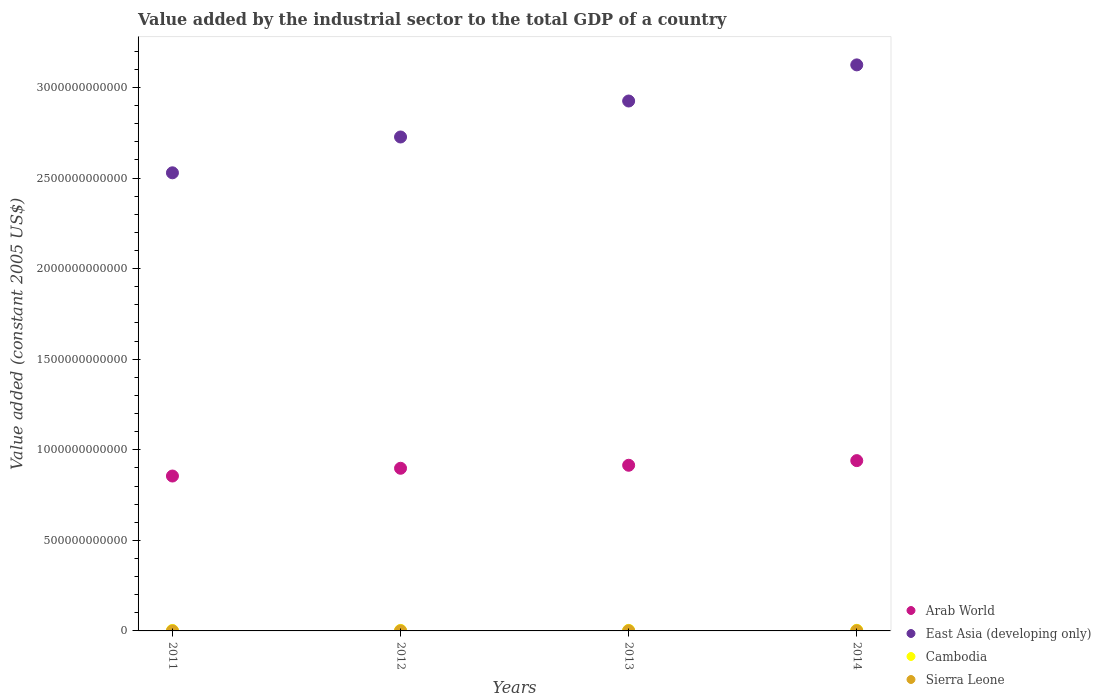How many different coloured dotlines are there?
Your response must be concise. 4. Is the number of dotlines equal to the number of legend labels?
Your response must be concise. Yes. What is the value added by the industrial sector in Cambodia in 2013?
Your answer should be compact. 3.00e+09. Across all years, what is the maximum value added by the industrial sector in Cambodia?
Make the answer very short. 3.29e+09. Across all years, what is the minimum value added by the industrial sector in East Asia (developing only)?
Offer a terse response. 2.53e+12. In which year was the value added by the industrial sector in East Asia (developing only) maximum?
Give a very brief answer. 2014. What is the total value added by the industrial sector in Cambodia in the graph?
Your answer should be very brief. 1.15e+1. What is the difference between the value added by the industrial sector in Sierra Leone in 2011 and that in 2012?
Your answer should be compact. -2.66e+08. What is the difference between the value added by the industrial sector in Arab World in 2011 and the value added by the industrial sector in Cambodia in 2013?
Provide a short and direct response. 8.52e+11. What is the average value added by the industrial sector in Sierra Leone per year?
Offer a very short reply. 6.73e+08. In the year 2011, what is the difference between the value added by the industrial sector in Sierra Leone and value added by the industrial sector in Arab World?
Keep it short and to the point. -8.55e+11. In how many years, is the value added by the industrial sector in Sierra Leone greater than 2800000000000 US$?
Your answer should be compact. 0. What is the ratio of the value added by the industrial sector in Sierra Leone in 2012 to that in 2014?
Your answer should be compact. 0.44. Is the value added by the industrial sector in East Asia (developing only) in 2011 less than that in 2013?
Your answer should be compact. Yes. Is the difference between the value added by the industrial sector in Sierra Leone in 2013 and 2014 greater than the difference between the value added by the industrial sector in Arab World in 2013 and 2014?
Offer a terse response. Yes. What is the difference between the highest and the second highest value added by the industrial sector in Cambodia?
Give a very brief answer. 2.95e+08. What is the difference between the highest and the lowest value added by the industrial sector in Cambodia?
Your response must be concise. 8.21e+08. Is it the case that in every year, the sum of the value added by the industrial sector in Cambodia and value added by the industrial sector in Arab World  is greater than the value added by the industrial sector in East Asia (developing only)?
Offer a very short reply. No. Is the value added by the industrial sector in Sierra Leone strictly greater than the value added by the industrial sector in Cambodia over the years?
Provide a succinct answer. No. Is the value added by the industrial sector in Arab World strictly less than the value added by the industrial sector in Cambodia over the years?
Offer a very short reply. No. What is the difference between two consecutive major ticks on the Y-axis?
Give a very brief answer. 5.00e+11. Does the graph contain any zero values?
Provide a short and direct response. No. Does the graph contain grids?
Provide a short and direct response. No. How are the legend labels stacked?
Your response must be concise. Vertical. What is the title of the graph?
Offer a very short reply. Value added by the industrial sector to the total GDP of a country. Does "Guyana" appear as one of the legend labels in the graph?
Your response must be concise. No. What is the label or title of the X-axis?
Provide a succinct answer. Years. What is the label or title of the Y-axis?
Ensure brevity in your answer.  Value added (constant 2005 US$). What is the Value added (constant 2005 US$) in Arab World in 2011?
Make the answer very short. 8.55e+11. What is the Value added (constant 2005 US$) in East Asia (developing only) in 2011?
Your answer should be compact. 2.53e+12. What is the Value added (constant 2005 US$) in Cambodia in 2011?
Your answer should be very brief. 2.47e+09. What is the Value added (constant 2005 US$) in Sierra Leone in 2011?
Keep it short and to the point. 2.09e+08. What is the Value added (constant 2005 US$) in Arab World in 2012?
Give a very brief answer. 8.98e+11. What is the Value added (constant 2005 US$) of East Asia (developing only) in 2012?
Give a very brief answer. 2.73e+12. What is the Value added (constant 2005 US$) in Cambodia in 2012?
Offer a very short reply. 2.70e+09. What is the Value added (constant 2005 US$) of Sierra Leone in 2012?
Your answer should be compact. 4.75e+08. What is the Value added (constant 2005 US$) of Arab World in 2013?
Offer a terse response. 9.15e+11. What is the Value added (constant 2005 US$) in East Asia (developing only) in 2013?
Keep it short and to the point. 2.93e+12. What is the Value added (constant 2005 US$) of Cambodia in 2013?
Your response must be concise. 3.00e+09. What is the Value added (constant 2005 US$) in Sierra Leone in 2013?
Keep it short and to the point. 9.39e+08. What is the Value added (constant 2005 US$) in Arab World in 2014?
Offer a very short reply. 9.40e+11. What is the Value added (constant 2005 US$) of East Asia (developing only) in 2014?
Provide a short and direct response. 3.12e+12. What is the Value added (constant 2005 US$) in Cambodia in 2014?
Your answer should be compact. 3.29e+09. What is the Value added (constant 2005 US$) of Sierra Leone in 2014?
Make the answer very short. 1.07e+09. Across all years, what is the maximum Value added (constant 2005 US$) in Arab World?
Your answer should be compact. 9.40e+11. Across all years, what is the maximum Value added (constant 2005 US$) in East Asia (developing only)?
Offer a terse response. 3.12e+12. Across all years, what is the maximum Value added (constant 2005 US$) in Cambodia?
Ensure brevity in your answer.  3.29e+09. Across all years, what is the maximum Value added (constant 2005 US$) in Sierra Leone?
Offer a terse response. 1.07e+09. Across all years, what is the minimum Value added (constant 2005 US$) of Arab World?
Provide a succinct answer. 8.55e+11. Across all years, what is the minimum Value added (constant 2005 US$) of East Asia (developing only)?
Ensure brevity in your answer.  2.53e+12. Across all years, what is the minimum Value added (constant 2005 US$) in Cambodia?
Your answer should be very brief. 2.47e+09. Across all years, what is the minimum Value added (constant 2005 US$) of Sierra Leone?
Offer a terse response. 2.09e+08. What is the total Value added (constant 2005 US$) of Arab World in the graph?
Give a very brief answer. 3.61e+12. What is the total Value added (constant 2005 US$) of East Asia (developing only) in the graph?
Your answer should be compact. 1.13e+13. What is the total Value added (constant 2005 US$) in Cambodia in the graph?
Make the answer very short. 1.15e+1. What is the total Value added (constant 2005 US$) of Sierra Leone in the graph?
Ensure brevity in your answer.  2.69e+09. What is the difference between the Value added (constant 2005 US$) of Arab World in 2011 and that in 2012?
Offer a terse response. -4.28e+1. What is the difference between the Value added (constant 2005 US$) of East Asia (developing only) in 2011 and that in 2012?
Your answer should be very brief. -1.98e+11. What is the difference between the Value added (constant 2005 US$) of Cambodia in 2011 and that in 2012?
Provide a succinct answer. -2.30e+08. What is the difference between the Value added (constant 2005 US$) in Sierra Leone in 2011 and that in 2012?
Your response must be concise. -2.66e+08. What is the difference between the Value added (constant 2005 US$) of Arab World in 2011 and that in 2013?
Provide a short and direct response. -5.94e+1. What is the difference between the Value added (constant 2005 US$) of East Asia (developing only) in 2011 and that in 2013?
Offer a terse response. -3.96e+11. What is the difference between the Value added (constant 2005 US$) in Cambodia in 2011 and that in 2013?
Offer a very short reply. -5.27e+08. What is the difference between the Value added (constant 2005 US$) of Sierra Leone in 2011 and that in 2013?
Give a very brief answer. -7.31e+08. What is the difference between the Value added (constant 2005 US$) in Arab World in 2011 and that in 2014?
Offer a terse response. -8.50e+1. What is the difference between the Value added (constant 2005 US$) in East Asia (developing only) in 2011 and that in 2014?
Keep it short and to the point. -5.96e+11. What is the difference between the Value added (constant 2005 US$) in Cambodia in 2011 and that in 2014?
Provide a short and direct response. -8.21e+08. What is the difference between the Value added (constant 2005 US$) of Sierra Leone in 2011 and that in 2014?
Ensure brevity in your answer.  -8.60e+08. What is the difference between the Value added (constant 2005 US$) in Arab World in 2012 and that in 2013?
Your answer should be very brief. -1.66e+1. What is the difference between the Value added (constant 2005 US$) in East Asia (developing only) in 2012 and that in 2013?
Your answer should be compact. -1.99e+11. What is the difference between the Value added (constant 2005 US$) of Cambodia in 2012 and that in 2013?
Keep it short and to the point. -2.96e+08. What is the difference between the Value added (constant 2005 US$) in Sierra Leone in 2012 and that in 2013?
Offer a terse response. -4.65e+08. What is the difference between the Value added (constant 2005 US$) of Arab World in 2012 and that in 2014?
Make the answer very short. -4.22e+1. What is the difference between the Value added (constant 2005 US$) in East Asia (developing only) in 2012 and that in 2014?
Your response must be concise. -3.98e+11. What is the difference between the Value added (constant 2005 US$) in Cambodia in 2012 and that in 2014?
Provide a short and direct response. -5.91e+08. What is the difference between the Value added (constant 2005 US$) of Sierra Leone in 2012 and that in 2014?
Offer a very short reply. -5.94e+08. What is the difference between the Value added (constant 2005 US$) of Arab World in 2013 and that in 2014?
Offer a terse response. -2.56e+1. What is the difference between the Value added (constant 2005 US$) in East Asia (developing only) in 2013 and that in 2014?
Your response must be concise. -2.00e+11. What is the difference between the Value added (constant 2005 US$) in Cambodia in 2013 and that in 2014?
Offer a very short reply. -2.95e+08. What is the difference between the Value added (constant 2005 US$) in Sierra Leone in 2013 and that in 2014?
Offer a terse response. -1.30e+08. What is the difference between the Value added (constant 2005 US$) in Arab World in 2011 and the Value added (constant 2005 US$) in East Asia (developing only) in 2012?
Give a very brief answer. -1.87e+12. What is the difference between the Value added (constant 2005 US$) of Arab World in 2011 and the Value added (constant 2005 US$) of Cambodia in 2012?
Give a very brief answer. 8.52e+11. What is the difference between the Value added (constant 2005 US$) of Arab World in 2011 and the Value added (constant 2005 US$) of Sierra Leone in 2012?
Make the answer very short. 8.55e+11. What is the difference between the Value added (constant 2005 US$) of East Asia (developing only) in 2011 and the Value added (constant 2005 US$) of Cambodia in 2012?
Ensure brevity in your answer.  2.53e+12. What is the difference between the Value added (constant 2005 US$) in East Asia (developing only) in 2011 and the Value added (constant 2005 US$) in Sierra Leone in 2012?
Your response must be concise. 2.53e+12. What is the difference between the Value added (constant 2005 US$) in Cambodia in 2011 and the Value added (constant 2005 US$) in Sierra Leone in 2012?
Your answer should be very brief. 1.99e+09. What is the difference between the Value added (constant 2005 US$) in Arab World in 2011 and the Value added (constant 2005 US$) in East Asia (developing only) in 2013?
Give a very brief answer. -2.07e+12. What is the difference between the Value added (constant 2005 US$) of Arab World in 2011 and the Value added (constant 2005 US$) of Cambodia in 2013?
Provide a succinct answer. 8.52e+11. What is the difference between the Value added (constant 2005 US$) of Arab World in 2011 and the Value added (constant 2005 US$) of Sierra Leone in 2013?
Offer a very short reply. 8.54e+11. What is the difference between the Value added (constant 2005 US$) of East Asia (developing only) in 2011 and the Value added (constant 2005 US$) of Cambodia in 2013?
Keep it short and to the point. 2.53e+12. What is the difference between the Value added (constant 2005 US$) of East Asia (developing only) in 2011 and the Value added (constant 2005 US$) of Sierra Leone in 2013?
Offer a very short reply. 2.53e+12. What is the difference between the Value added (constant 2005 US$) of Cambodia in 2011 and the Value added (constant 2005 US$) of Sierra Leone in 2013?
Provide a succinct answer. 1.53e+09. What is the difference between the Value added (constant 2005 US$) in Arab World in 2011 and the Value added (constant 2005 US$) in East Asia (developing only) in 2014?
Ensure brevity in your answer.  -2.27e+12. What is the difference between the Value added (constant 2005 US$) of Arab World in 2011 and the Value added (constant 2005 US$) of Cambodia in 2014?
Your answer should be compact. 8.52e+11. What is the difference between the Value added (constant 2005 US$) of Arab World in 2011 and the Value added (constant 2005 US$) of Sierra Leone in 2014?
Offer a very short reply. 8.54e+11. What is the difference between the Value added (constant 2005 US$) in East Asia (developing only) in 2011 and the Value added (constant 2005 US$) in Cambodia in 2014?
Provide a short and direct response. 2.53e+12. What is the difference between the Value added (constant 2005 US$) in East Asia (developing only) in 2011 and the Value added (constant 2005 US$) in Sierra Leone in 2014?
Provide a succinct answer. 2.53e+12. What is the difference between the Value added (constant 2005 US$) of Cambodia in 2011 and the Value added (constant 2005 US$) of Sierra Leone in 2014?
Ensure brevity in your answer.  1.40e+09. What is the difference between the Value added (constant 2005 US$) of Arab World in 2012 and the Value added (constant 2005 US$) of East Asia (developing only) in 2013?
Ensure brevity in your answer.  -2.03e+12. What is the difference between the Value added (constant 2005 US$) in Arab World in 2012 and the Value added (constant 2005 US$) in Cambodia in 2013?
Offer a terse response. 8.95e+11. What is the difference between the Value added (constant 2005 US$) of Arab World in 2012 and the Value added (constant 2005 US$) of Sierra Leone in 2013?
Your answer should be very brief. 8.97e+11. What is the difference between the Value added (constant 2005 US$) of East Asia (developing only) in 2012 and the Value added (constant 2005 US$) of Cambodia in 2013?
Ensure brevity in your answer.  2.72e+12. What is the difference between the Value added (constant 2005 US$) of East Asia (developing only) in 2012 and the Value added (constant 2005 US$) of Sierra Leone in 2013?
Your response must be concise. 2.73e+12. What is the difference between the Value added (constant 2005 US$) of Cambodia in 2012 and the Value added (constant 2005 US$) of Sierra Leone in 2013?
Offer a terse response. 1.76e+09. What is the difference between the Value added (constant 2005 US$) of Arab World in 2012 and the Value added (constant 2005 US$) of East Asia (developing only) in 2014?
Give a very brief answer. -2.23e+12. What is the difference between the Value added (constant 2005 US$) of Arab World in 2012 and the Value added (constant 2005 US$) of Cambodia in 2014?
Your answer should be compact. 8.95e+11. What is the difference between the Value added (constant 2005 US$) of Arab World in 2012 and the Value added (constant 2005 US$) of Sierra Leone in 2014?
Your answer should be very brief. 8.97e+11. What is the difference between the Value added (constant 2005 US$) in East Asia (developing only) in 2012 and the Value added (constant 2005 US$) in Cambodia in 2014?
Provide a succinct answer. 2.72e+12. What is the difference between the Value added (constant 2005 US$) of East Asia (developing only) in 2012 and the Value added (constant 2005 US$) of Sierra Leone in 2014?
Give a very brief answer. 2.73e+12. What is the difference between the Value added (constant 2005 US$) in Cambodia in 2012 and the Value added (constant 2005 US$) in Sierra Leone in 2014?
Your answer should be very brief. 1.63e+09. What is the difference between the Value added (constant 2005 US$) in Arab World in 2013 and the Value added (constant 2005 US$) in East Asia (developing only) in 2014?
Your response must be concise. -2.21e+12. What is the difference between the Value added (constant 2005 US$) in Arab World in 2013 and the Value added (constant 2005 US$) in Cambodia in 2014?
Offer a very short reply. 9.11e+11. What is the difference between the Value added (constant 2005 US$) of Arab World in 2013 and the Value added (constant 2005 US$) of Sierra Leone in 2014?
Provide a short and direct response. 9.14e+11. What is the difference between the Value added (constant 2005 US$) of East Asia (developing only) in 2013 and the Value added (constant 2005 US$) of Cambodia in 2014?
Make the answer very short. 2.92e+12. What is the difference between the Value added (constant 2005 US$) of East Asia (developing only) in 2013 and the Value added (constant 2005 US$) of Sierra Leone in 2014?
Ensure brevity in your answer.  2.92e+12. What is the difference between the Value added (constant 2005 US$) in Cambodia in 2013 and the Value added (constant 2005 US$) in Sierra Leone in 2014?
Your answer should be very brief. 1.93e+09. What is the average Value added (constant 2005 US$) of Arab World per year?
Keep it short and to the point. 9.02e+11. What is the average Value added (constant 2005 US$) in East Asia (developing only) per year?
Ensure brevity in your answer.  2.83e+12. What is the average Value added (constant 2005 US$) of Cambodia per year?
Make the answer very short. 2.86e+09. What is the average Value added (constant 2005 US$) in Sierra Leone per year?
Your response must be concise. 6.73e+08. In the year 2011, what is the difference between the Value added (constant 2005 US$) in Arab World and Value added (constant 2005 US$) in East Asia (developing only)?
Make the answer very short. -1.67e+12. In the year 2011, what is the difference between the Value added (constant 2005 US$) of Arab World and Value added (constant 2005 US$) of Cambodia?
Make the answer very short. 8.53e+11. In the year 2011, what is the difference between the Value added (constant 2005 US$) of Arab World and Value added (constant 2005 US$) of Sierra Leone?
Give a very brief answer. 8.55e+11. In the year 2011, what is the difference between the Value added (constant 2005 US$) in East Asia (developing only) and Value added (constant 2005 US$) in Cambodia?
Ensure brevity in your answer.  2.53e+12. In the year 2011, what is the difference between the Value added (constant 2005 US$) of East Asia (developing only) and Value added (constant 2005 US$) of Sierra Leone?
Provide a succinct answer. 2.53e+12. In the year 2011, what is the difference between the Value added (constant 2005 US$) in Cambodia and Value added (constant 2005 US$) in Sierra Leone?
Give a very brief answer. 2.26e+09. In the year 2012, what is the difference between the Value added (constant 2005 US$) in Arab World and Value added (constant 2005 US$) in East Asia (developing only)?
Provide a short and direct response. -1.83e+12. In the year 2012, what is the difference between the Value added (constant 2005 US$) of Arab World and Value added (constant 2005 US$) of Cambodia?
Offer a very short reply. 8.95e+11. In the year 2012, what is the difference between the Value added (constant 2005 US$) of Arab World and Value added (constant 2005 US$) of Sierra Leone?
Provide a short and direct response. 8.97e+11. In the year 2012, what is the difference between the Value added (constant 2005 US$) in East Asia (developing only) and Value added (constant 2005 US$) in Cambodia?
Your response must be concise. 2.72e+12. In the year 2012, what is the difference between the Value added (constant 2005 US$) of East Asia (developing only) and Value added (constant 2005 US$) of Sierra Leone?
Offer a terse response. 2.73e+12. In the year 2012, what is the difference between the Value added (constant 2005 US$) of Cambodia and Value added (constant 2005 US$) of Sierra Leone?
Offer a terse response. 2.22e+09. In the year 2013, what is the difference between the Value added (constant 2005 US$) in Arab World and Value added (constant 2005 US$) in East Asia (developing only)?
Provide a succinct answer. -2.01e+12. In the year 2013, what is the difference between the Value added (constant 2005 US$) of Arab World and Value added (constant 2005 US$) of Cambodia?
Your answer should be very brief. 9.12e+11. In the year 2013, what is the difference between the Value added (constant 2005 US$) of Arab World and Value added (constant 2005 US$) of Sierra Leone?
Your response must be concise. 9.14e+11. In the year 2013, what is the difference between the Value added (constant 2005 US$) of East Asia (developing only) and Value added (constant 2005 US$) of Cambodia?
Your response must be concise. 2.92e+12. In the year 2013, what is the difference between the Value added (constant 2005 US$) of East Asia (developing only) and Value added (constant 2005 US$) of Sierra Leone?
Give a very brief answer. 2.92e+12. In the year 2013, what is the difference between the Value added (constant 2005 US$) in Cambodia and Value added (constant 2005 US$) in Sierra Leone?
Your response must be concise. 2.06e+09. In the year 2014, what is the difference between the Value added (constant 2005 US$) of Arab World and Value added (constant 2005 US$) of East Asia (developing only)?
Your response must be concise. -2.18e+12. In the year 2014, what is the difference between the Value added (constant 2005 US$) in Arab World and Value added (constant 2005 US$) in Cambodia?
Provide a succinct answer. 9.37e+11. In the year 2014, what is the difference between the Value added (constant 2005 US$) in Arab World and Value added (constant 2005 US$) in Sierra Leone?
Your answer should be very brief. 9.39e+11. In the year 2014, what is the difference between the Value added (constant 2005 US$) of East Asia (developing only) and Value added (constant 2005 US$) of Cambodia?
Your answer should be compact. 3.12e+12. In the year 2014, what is the difference between the Value added (constant 2005 US$) of East Asia (developing only) and Value added (constant 2005 US$) of Sierra Leone?
Provide a succinct answer. 3.12e+12. In the year 2014, what is the difference between the Value added (constant 2005 US$) of Cambodia and Value added (constant 2005 US$) of Sierra Leone?
Offer a very short reply. 2.22e+09. What is the ratio of the Value added (constant 2005 US$) of Arab World in 2011 to that in 2012?
Offer a very short reply. 0.95. What is the ratio of the Value added (constant 2005 US$) in East Asia (developing only) in 2011 to that in 2012?
Offer a very short reply. 0.93. What is the ratio of the Value added (constant 2005 US$) of Cambodia in 2011 to that in 2012?
Make the answer very short. 0.91. What is the ratio of the Value added (constant 2005 US$) in Sierra Leone in 2011 to that in 2012?
Make the answer very short. 0.44. What is the ratio of the Value added (constant 2005 US$) in Arab World in 2011 to that in 2013?
Your answer should be compact. 0.94. What is the ratio of the Value added (constant 2005 US$) of East Asia (developing only) in 2011 to that in 2013?
Your response must be concise. 0.86. What is the ratio of the Value added (constant 2005 US$) in Cambodia in 2011 to that in 2013?
Make the answer very short. 0.82. What is the ratio of the Value added (constant 2005 US$) of Sierra Leone in 2011 to that in 2013?
Your answer should be compact. 0.22. What is the ratio of the Value added (constant 2005 US$) in Arab World in 2011 to that in 2014?
Your response must be concise. 0.91. What is the ratio of the Value added (constant 2005 US$) of East Asia (developing only) in 2011 to that in 2014?
Ensure brevity in your answer.  0.81. What is the ratio of the Value added (constant 2005 US$) in Cambodia in 2011 to that in 2014?
Offer a terse response. 0.75. What is the ratio of the Value added (constant 2005 US$) of Sierra Leone in 2011 to that in 2014?
Give a very brief answer. 0.2. What is the ratio of the Value added (constant 2005 US$) in Arab World in 2012 to that in 2013?
Provide a short and direct response. 0.98. What is the ratio of the Value added (constant 2005 US$) of East Asia (developing only) in 2012 to that in 2013?
Make the answer very short. 0.93. What is the ratio of the Value added (constant 2005 US$) of Cambodia in 2012 to that in 2013?
Offer a very short reply. 0.9. What is the ratio of the Value added (constant 2005 US$) of Sierra Leone in 2012 to that in 2013?
Give a very brief answer. 0.51. What is the ratio of the Value added (constant 2005 US$) of Arab World in 2012 to that in 2014?
Keep it short and to the point. 0.96. What is the ratio of the Value added (constant 2005 US$) in East Asia (developing only) in 2012 to that in 2014?
Your response must be concise. 0.87. What is the ratio of the Value added (constant 2005 US$) of Cambodia in 2012 to that in 2014?
Your answer should be compact. 0.82. What is the ratio of the Value added (constant 2005 US$) in Sierra Leone in 2012 to that in 2014?
Ensure brevity in your answer.  0.44. What is the ratio of the Value added (constant 2005 US$) of Arab World in 2013 to that in 2014?
Keep it short and to the point. 0.97. What is the ratio of the Value added (constant 2005 US$) in East Asia (developing only) in 2013 to that in 2014?
Make the answer very short. 0.94. What is the ratio of the Value added (constant 2005 US$) in Cambodia in 2013 to that in 2014?
Make the answer very short. 0.91. What is the ratio of the Value added (constant 2005 US$) in Sierra Leone in 2013 to that in 2014?
Keep it short and to the point. 0.88. What is the difference between the highest and the second highest Value added (constant 2005 US$) in Arab World?
Your answer should be very brief. 2.56e+1. What is the difference between the highest and the second highest Value added (constant 2005 US$) in East Asia (developing only)?
Your answer should be compact. 2.00e+11. What is the difference between the highest and the second highest Value added (constant 2005 US$) of Cambodia?
Offer a terse response. 2.95e+08. What is the difference between the highest and the second highest Value added (constant 2005 US$) of Sierra Leone?
Offer a terse response. 1.30e+08. What is the difference between the highest and the lowest Value added (constant 2005 US$) of Arab World?
Make the answer very short. 8.50e+1. What is the difference between the highest and the lowest Value added (constant 2005 US$) of East Asia (developing only)?
Ensure brevity in your answer.  5.96e+11. What is the difference between the highest and the lowest Value added (constant 2005 US$) in Cambodia?
Your response must be concise. 8.21e+08. What is the difference between the highest and the lowest Value added (constant 2005 US$) in Sierra Leone?
Offer a terse response. 8.60e+08. 